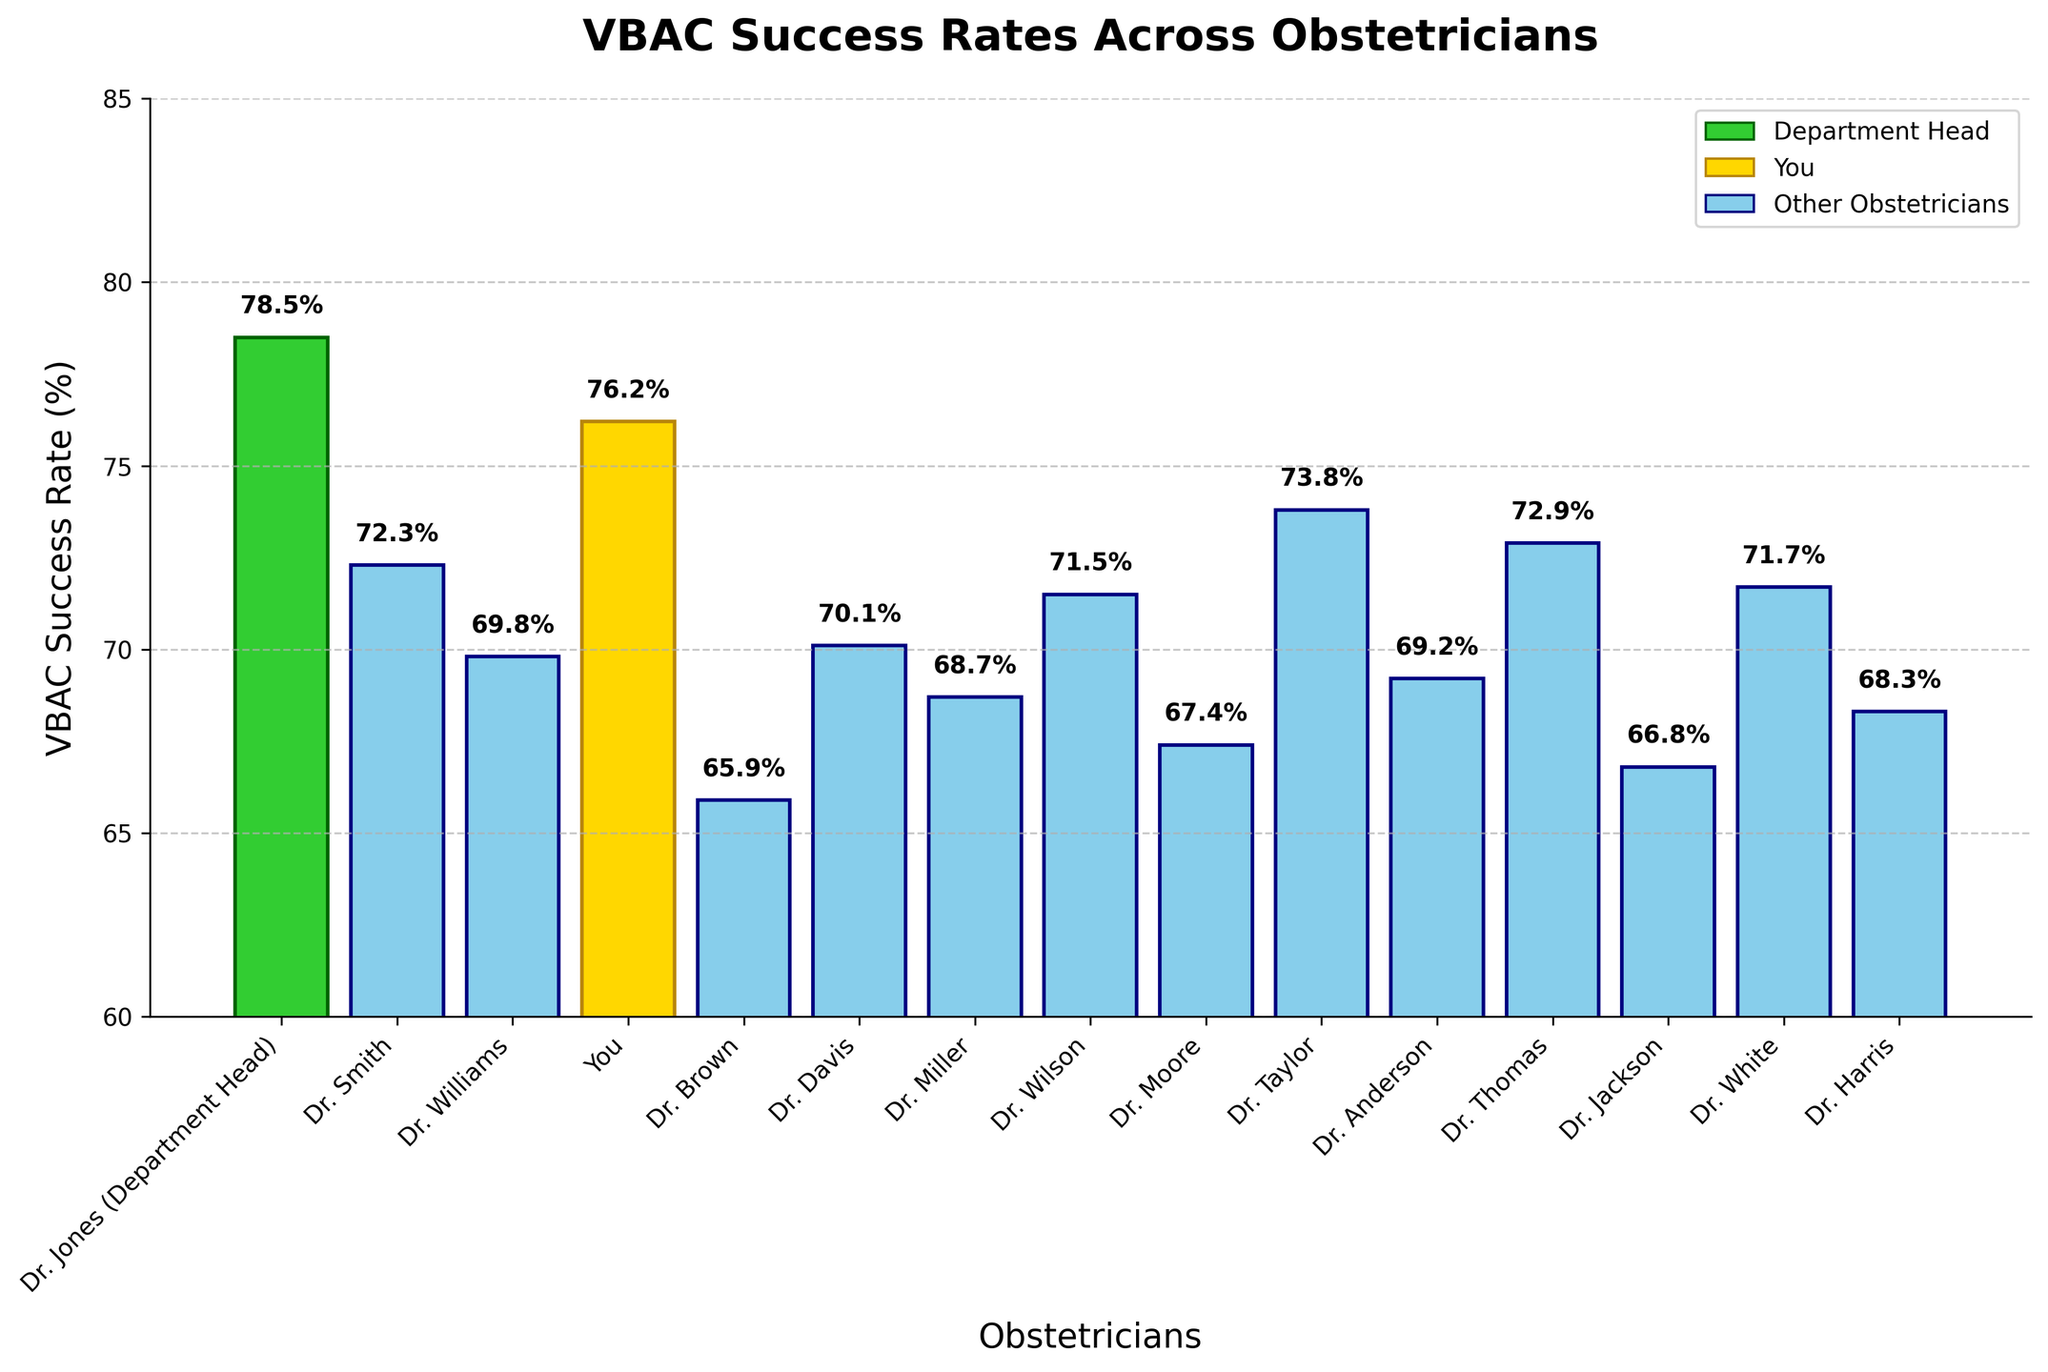What is the VBAC success rate for Dr. Williams? Look at the bar labeled 'Dr. Williams' and read the value at the top of the bar.
Answer: 69.8% Who has the highest VBAC success rate? Compare all bars and identify the tallest one, which corresponds to Dr. Jones (Department Head).
Answer: Dr. Jones (Department Head) Which obstetrician has the lowest VBAC success rate? Compare all bars and identify the shortest one, which corresponds to Dr. Brown.
Answer: Dr. Brown How much higher is your VBAC success rate compared to Dr. Brown? Find the difference between the values for 'You' (76.2%) and 'Dr. Brown' (65.9%) by subtracting the latter from the former.
Answer: 10.3% What is the average VBAC success rate across all obstetricians? Sum all the success rates and divide by the number of obstetricians (15).
Answer: 70.6% Are there any obstetricians with a VBAC success rate above 80%? Check the y-axis range and the values on top of the bars; none exceed 80%.
Answer: No How many obstetricians have a VBAC success rate of 70% or more? Count the bars with values of 70% or higher.
Answer: 9 What is the combined VBAC success rate of Dr. Wilson and Dr. Taylor? Add the success rates for Dr. Wilson (71.5%) and Dr. Taylor (73.8%).
Answer: 145.3% Which obstetricians have a higher VBAC success rate than the department average (70.6%)? Compare the success rates of each obstetrician to the average and note those above it.
Answer: Dr. Jones (Department Head), Dr. Smith, You, Dr. Taylor, Dr. Thomas Does 'You' have a higher VBAC success rate than Dr. Smith? Compare the corresponding values: 'You' have 76.2% and Dr. Smith has 72.3%.
Answer: Yes 